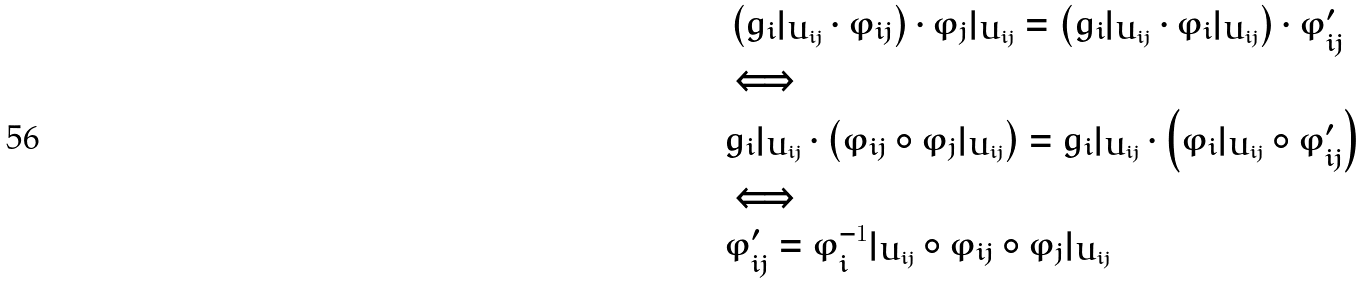Convert formula to latex. <formula><loc_0><loc_0><loc_500><loc_500>& \left ( g _ { i } | _ { U _ { i j } } \cdot \varphi _ { i j } \right ) \cdot \varphi _ { j } | _ { U _ { i j } } = \left ( g _ { i } | _ { U _ { i j } } \cdot \varphi _ { i } | _ { U _ { i j } } \right ) \cdot \varphi _ { i j } ^ { \prime } \\ & \Longleftrightarrow \\ & g _ { i } | _ { U _ { i j } } \cdot \left ( \varphi _ { i j } \circ \varphi _ { j } | _ { U _ { i j } } \right ) = g _ { i } | _ { U _ { i j } } \cdot \left ( \varphi _ { i } | _ { U _ { i j } } \circ \varphi _ { i j } ^ { \prime } \right ) \\ & \Longleftrightarrow \\ & \varphi _ { i j } ^ { \prime } = \varphi _ { i } ^ { - 1 } | _ { U _ { i j } } \circ \varphi _ { i j } \circ \varphi _ { j } | _ { U _ { i j } }</formula> 